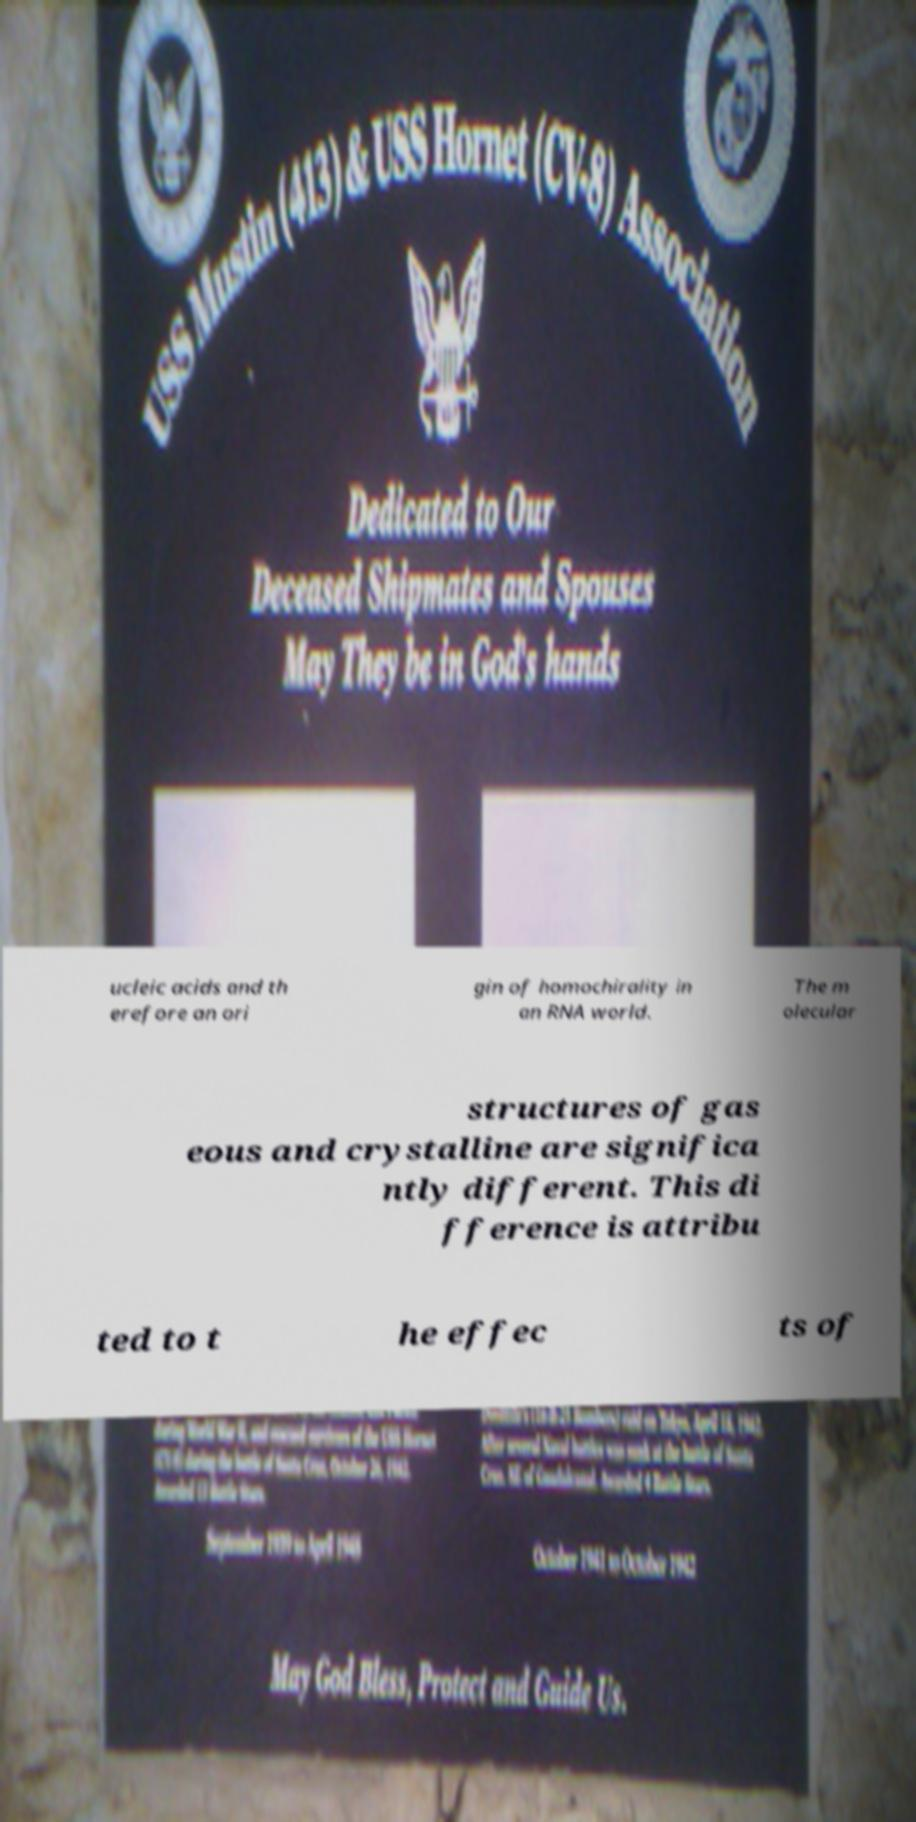For documentation purposes, I need the text within this image transcribed. Could you provide that? ucleic acids and th erefore an ori gin of homochirality in an RNA world. The m olecular structures of gas eous and crystalline are significa ntly different. This di fference is attribu ted to t he effec ts of 